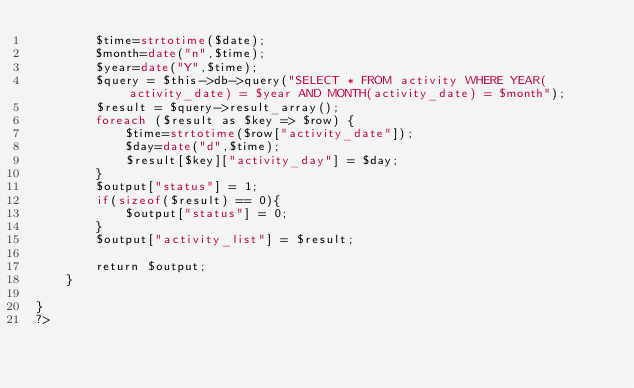<code> <loc_0><loc_0><loc_500><loc_500><_PHP_>        $time=strtotime($date);
        $month=date("n",$time);
        $year=date("Y",$time);
        $query = $this->db->query("SELECT * FROM activity WHERE YEAR(activity_date) = $year AND MONTH(activity_date) = $month");
        $result = $query->result_array();
        foreach ($result as $key => $row) {
            $time=strtotime($row["activity_date"]);
            $day=date("d",$time);
            $result[$key]["activity_day"] = $day;
        }
        $output["status"] = 1;
        if(sizeof($result) == 0){
            $output["status"] = 0;
        }
        $output["activity_list"] = $result;
        
        return $output;
    }

}
?></code> 